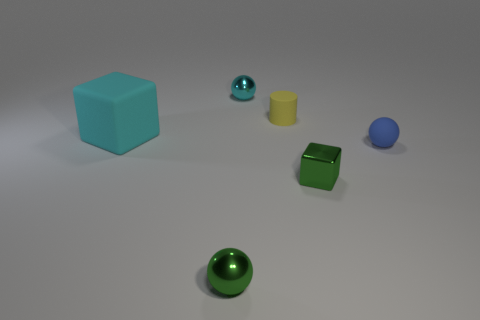There is a rubber object that is on the right side of the cyan matte thing and left of the blue rubber object; what size is it?
Keep it short and to the point. Small. Are there any other red matte spheres of the same size as the rubber ball?
Provide a succinct answer. No. Are there more things in front of the large matte thing than rubber spheres that are behind the yellow cylinder?
Offer a terse response. Yes. Does the green ball have the same material as the cyan thing that is behind the small matte cylinder?
Your response must be concise. Yes. How many matte cylinders are behind the sphere in front of the small sphere right of the green block?
Provide a short and direct response. 1. There is a cyan shiny thing; is it the same shape as the tiny rubber thing that is in front of the large cyan rubber thing?
Offer a terse response. Yes. The thing that is behind the large matte block and in front of the tiny cyan sphere is what color?
Provide a succinct answer. Yellow. What material is the green thing that is left of the tiny metallic ball to the right of the tiny metal sphere in front of the blue matte thing?
Give a very brief answer. Metal. What material is the cylinder?
Offer a very short reply. Rubber. Are there the same number of small cyan objects that are to the left of the big cube and tiny yellow matte cylinders?
Your answer should be very brief. No. 